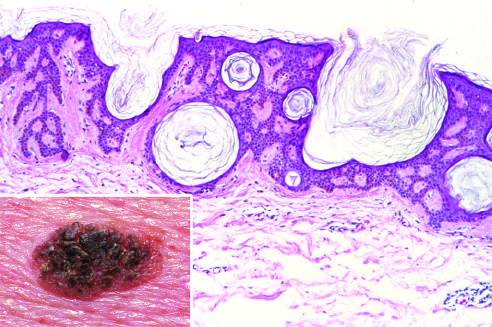what does microscopic examination show?
Answer the question using a single word or phrase. An orderly proliferation of uniform 